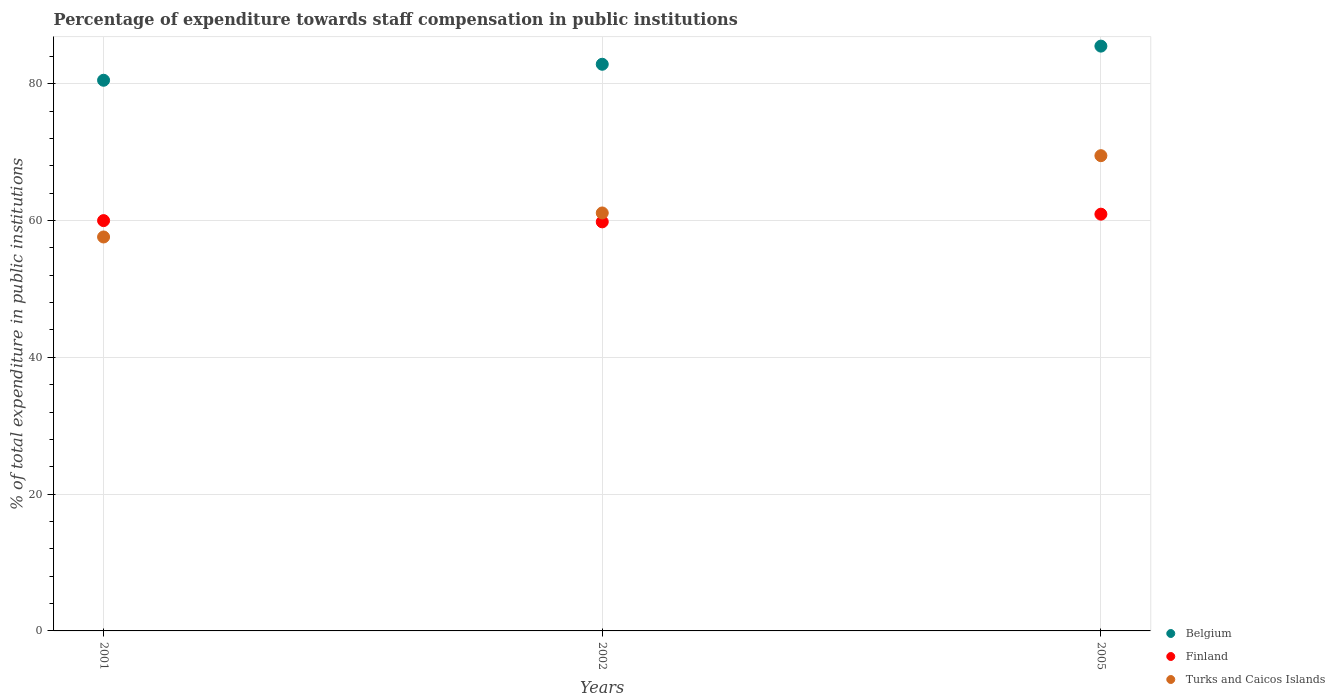How many different coloured dotlines are there?
Offer a terse response. 3. What is the percentage of expenditure towards staff compensation in Belgium in 2005?
Give a very brief answer. 85.49. Across all years, what is the maximum percentage of expenditure towards staff compensation in Belgium?
Offer a terse response. 85.49. Across all years, what is the minimum percentage of expenditure towards staff compensation in Turks and Caicos Islands?
Provide a short and direct response. 57.59. In which year was the percentage of expenditure towards staff compensation in Finland maximum?
Keep it short and to the point. 2005. In which year was the percentage of expenditure towards staff compensation in Finland minimum?
Give a very brief answer. 2002. What is the total percentage of expenditure towards staff compensation in Finland in the graph?
Provide a succinct answer. 180.7. What is the difference between the percentage of expenditure towards staff compensation in Turks and Caicos Islands in 2001 and that in 2005?
Make the answer very short. -11.88. What is the difference between the percentage of expenditure towards staff compensation in Belgium in 2005 and the percentage of expenditure towards staff compensation in Finland in 2001?
Offer a terse response. 25.51. What is the average percentage of expenditure towards staff compensation in Finland per year?
Offer a very short reply. 60.23. In the year 2005, what is the difference between the percentage of expenditure towards staff compensation in Belgium and percentage of expenditure towards staff compensation in Turks and Caicos Islands?
Your answer should be compact. 16.01. In how many years, is the percentage of expenditure towards staff compensation in Finland greater than 24 %?
Offer a terse response. 3. What is the ratio of the percentage of expenditure towards staff compensation in Finland in 2001 to that in 2002?
Give a very brief answer. 1. What is the difference between the highest and the second highest percentage of expenditure towards staff compensation in Finland?
Make the answer very short. 0.94. What is the difference between the highest and the lowest percentage of expenditure towards staff compensation in Finland?
Offer a very short reply. 1.12. Is it the case that in every year, the sum of the percentage of expenditure towards staff compensation in Belgium and percentage of expenditure towards staff compensation in Turks and Caicos Islands  is greater than the percentage of expenditure towards staff compensation in Finland?
Offer a terse response. Yes. Does the percentage of expenditure towards staff compensation in Turks and Caicos Islands monotonically increase over the years?
Your answer should be very brief. Yes. Is the percentage of expenditure towards staff compensation in Turks and Caicos Islands strictly greater than the percentage of expenditure towards staff compensation in Belgium over the years?
Provide a short and direct response. No. How many dotlines are there?
Ensure brevity in your answer.  3. Does the graph contain any zero values?
Give a very brief answer. No. Does the graph contain grids?
Make the answer very short. Yes. How are the legend labels stacked?
Ensure brevity in your answer.  Vertical. What is the title of the graph?
Your response must be concise. Percentage of expenditure towards staff compensation in public institutions. Does "Northern Mariana Islands" appear as one of the legend labels in the graph?
Ensure brevity in your answer.  No. What is the label or title of the X-axis?
Provide a short and direct response. Years. What is the label or title of the Y-axis?
Provide a short and direct response. % of total expenditure in public institutions. What is the % of total expenditure in public institutions in Belgium in 2001?
Provide a short and direct response. 80.5. What is the % of total expenditure in public institutions in Finland in 2001?
Provide a succinct answer. 59.98. What is the % of total expenditure in public institutions in Turks and Caicos Islands in 2001?
Your response must be concise. 57.59. What is the % of total expenditure in public institutions in Belgium in 2002?
Keep it short and to the point. 82.83. What is the % of total expenditure in public institutions in Finland in 2002?
Offer a terse response. 59.8. What is the % of total expenditure in public institutions of Turks and Caicos Islands in 2002?
Give a very brief answer. 61.1. What is the % of total expenditure in public institutions of Belgium in 2005?
Offer a very short reply. 85.49. What is the % of total expenditure in public institutions of Finland in 2005?
Your answer should be very brief. 60.92. What is the % of total expenditure in public institutions of Turks and Caicos Islands in 2005?
Provide a succinct answer. 69.47. Across all years, what is the maximum % of total expenditure in public institutions of Belgium?
Ensure brevity in your answer.  85.49. Across all years, what is the maximum % of total expenditure in public institutions of Finland?
Give a very brief answer. 60.92. Across all years, what is the maximum % of total expenditure in public institutions of Turks and Caicos Islands?
Make the answer very short. 69.47. Across all years, what is the minimum % of total expenditure in public institutions of Belgium?
Your answer should be very brief. 80.5. Across all years, what is the minimum % of total expenditure in public institutions in Finland?
Give a very brief answer. 59.8. Across all years, what is the minimum % of total expenditure in public institutions in Turks and Caicos Islands?
Your answer should be very brief. 57.59. What is the total % of total expenditure in public institutions in Belgium in the graph?
Your response must be concise. 248.82. What is the total % of total expenditure in public institutions of Finland in the graph?
Give a very brief answer. 180.7. What is the total % of total expenditure in public institutions of Turks and Caicos Islands in the graph?
Make the answer very short. 188.16. What is the difference between the % of total expenditure in public institutions in Belgium in 2001 and that in 2002?
Keep it short and to the point. -2.34. What is the difference between the % of total expenditure in public institutions of Finland in 2001 and that in 2002?
Provide a short and direct response. 0.18. What is the difference between the % of total expenditure in public institutions of Turks and Caicos Islands in 2001 and that in 2002?
Your response must be concise. -3.51. What is the difference between the % of total expenditure in public institutions of Belgium in 2001 and that in 2005?
Ensure brevity in your answer.  -4.99. What is the difference between the % of total expenditure in public institutions in Finland in 2001 and that in 2005?
Provide a short and direct response. -0.94. What is the difference between the % of total expenditure in public institutions in Turks and Caicos Islands in 2001 and that in 2005?
Offer a terse response. -11.88. What is the difference between the % of total expenditure in public institutions in Belgium in 2002 and that in 2005?
Keep it short and to the point. -2.65. What is the difference between the % of total expenditure in public institutions of Finland in 2002 and that in 2005?
Your response must be concise. -1.12. What is the difference between the % of total expenditure in public institutions in Turks and Caicos Islands in 2002 and that in 2005?
Make the answer very short. -8.37. What is the difference between the % of total expenditure in public institutions in Belgium in 2001 and the % of total expenditure in public institutions in Finland in 2002?
Offer a very short reply. 20.7. What is the difference between the % of total expenditure in public institutions in Belgium in 2001 and the % of total expenditure in public institutions in Turks and Caicos Islands in 2002?
Keep it short and to the point. 19.4. What is the difference between the % of total expenditure in public institutions in Finland in 2001 and the % of total expenditure in public institutions in Turks and Caicos Islands in 2002?
Keep it short and to the point. -1.12. What is the difference between the % of total expenditure in public institutions of Belgium in 2001 and the % of total expenditure in public institutions of Finland in 2005?
Your response must be concise. 19.58. What is the difference between the % of total expenditure in public institutions of Belgium in 2001 and the % of total expenditure in public institutions of Turks and Caicos Islands in 2005?
Offer a very short reply. 11.02. What is the difference between the % of total expenditure in public institutions in Finland in 2001 and the % of total expenditure in public institutions in Turks and Caicos Islands in 2005?
Provide a succinct answer. -9.49. What is the difference between the % of total expenditure in public institutions of Belgium in 2002 and the % of total expenditure in public institutions of Finland in 2005?
Keep it short and to the point. 21.91. What is the difference between the % of total expenditure in public institutions in Belgium in 2002 and the % of total expenditure in public institutions in Turks and Caicos Islands in 2005?
Offer a very short reply. 13.36. What is the difference between the % of total expenditure in public institutions in Finland in 2002 and the % of total expenditure in public institutions in Turks and Caicos Islands in 2005?
Provide a short and direct response. -9.68. What is the average % of total expenditure in public institutions in Belgium per year?
Your answer should be compact. 82.94. What is the average % of total expenditure in public institutions of Finland per year?
Provide a succinct answer. 60.23. What is the average % of total expenditure in public institutions of Turks and Caicos Islands per year?
Make the answer very short. 62.72. In the year 2001, what is the difference between the % of total expenditure in public institutions in Belgium and % of total expenditure in public institutions in Finland?
Provide a short and direct response. 20.52. In the year 2001, what is the difference between the % of total expenditure in public institutions in Belgium and % of total expenditure in public institutions in Turks and Caicos Islands?
Your answer should be very brief. 22.91. In the year 2001, what is the difference between the % of total expenditure in public institutions of Finland and % of total expenditure in public institutions of Turks and Caicos Islands?
Make the answer very short. 2.39. In the year 2002, what is the difference between the % of total expenditure in public institutions in Belgium and % of total expenditure in public institutions in Finland?
Offer a terse response. 23.04. In the year 2002, what is the difference between the % of total expenditure in public institutions in Belgium and % of total expenditure in public institutions in Turks and Caicos Islands?
Keep it short and to the point. 21.74. In the year 2002, what is the difference between the % of total expenditure in public institutions in Finland and % of total expenditure in public institutions in Turks and Caicos Islands?
Keep it short and to the point. -1.3. In the year 2005, what is the difference between the % of total expenditure in public institutions of Belgium and % of total expenditure in public institutions of Finland?
Keep it short and to the point. 24.57. In the year 2005, what is the difference between the % of total expenditure in public institutions in Belgium and % of total expenditure in public institutions in Turks and Caicos Islands?
Offer a very short reply. 16.01. In the year 2005, what is the difference between the % of total expenditure in public institutions of Finland and % of total expenditure in public institutions of Turks and Caicos Islands?
Offer a very short reply. -8.55. What is the ratio of the % of total expenditure in public institutions of Belgium in 2001 to that in 2002?
Ensure brevity in your answer.  0.97. What is the ratio of the % of total expenditure in public institutions of Turks and Caicos Islands in 2001 to that in 2002?
Make the answer very short. 0.94. What is the ratio of the % of total expenditure in public institutions of Belgium in 2001 to that in 2005?
Provide a short and direct response. 0.94. What is the ratio of the % of total expenditure in public institutions in Finland in 2001 to that in 2005?
Provide a succinct answer. 0.98. What is the ratio of the % of total expenditure in public institutions of Turks and Caicos Islands in 2001 to that in 2005?
Provide a short and direct response. 0.83. What is the ratio of the % of total expenditure in public institutions of Finland in 2002 to that in 2005?
Offer a terse response. 0.98. What is the ratio of the % of total expenditure in public institutions of Turks and Caicos Islands in 2002 to that in 2005?
Give a very brief answer. 0.88. What is the difference between the highest and the second highest % of total expenditure in public institutions in Belgium?
Provide a succinct answer. 2.65. What is the difference between the highest and the second highest % of total expenditure in public institutions of Finland?
Your response must be concise. 0.94. What is the difference between the highest and the second highest % of total expenditure in public institutions in Turks and Caicos Islands?
Give a very brief answer. 8.37. What is the difference between the highest and the lowest % of total expenditure in public institutions of Belgium?
Make the answer very short. 4.99. What is the difference between the highest and the lowest % of total expenditure in public institutions of Finland?
Ensure brevity in your answer.  1.12. What is the difference between the highest and the lowest % of total expenditure in public institutions of Turks and Caicos Islands?
Your response must be concise. 11.88. 